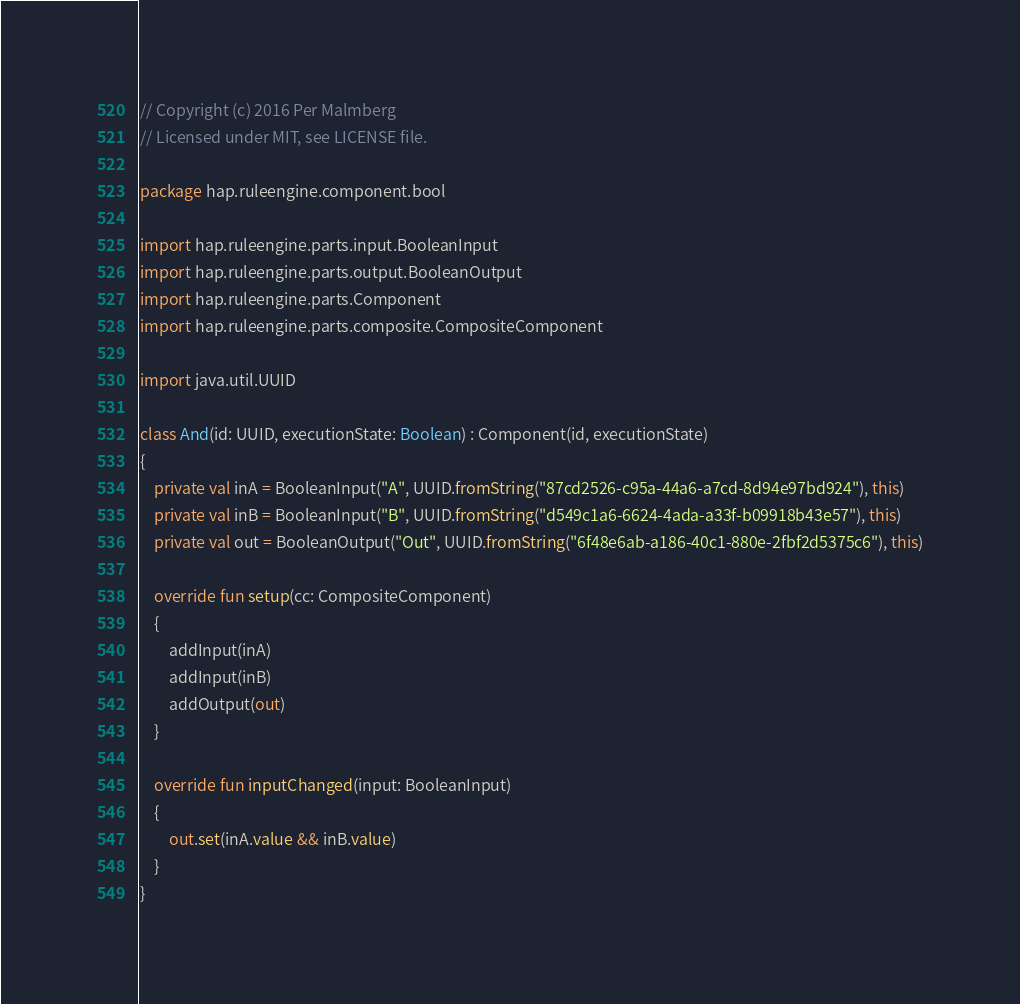Convert code to text. <code><loc_0><loc_0><loc_500><loc_500><_Kotlin_>// Copyright (c) 2016 Per Malmberg
// Licensed under MIT, see LICENSE file.

package hap.ruleengine.component.bool

import hap.ruleengine.parts.input.BooleanInput
import hap.ruleengine.parts.output.BooleanOutput
import hap.ruleengine.parts.Component
import hap.ruleengine.parts.composite.CompositeComponent

import java.util.UUID

class And(id: UUID, executionState: Boolean) : Component(id, executionState)
{
	private val inA = BooleanInput("A", UUID.fromString("87cd2526-c95a-44a6-a7cd-8d94e97bd924"), this)
	private val inB = BooleanInput("B", UUID.fromString("d549c1a6-6624-4ada-a33f-b09918b43e57"), this)
	private val out = BooleanOutput("Out", UUID.fromString("6f48e6ab-a186-40c1-880e-2fbf2d5375c6"), this)

	override fun setup(cc: CompositeComponent)
	{
		addInput(inA)
		addInput(inB)
		addOutput(out)
	}

	override fun inputChanged(input: BooleanInput)
	{
		out.set(inA.value && inB.value)
	}
}
</code> 